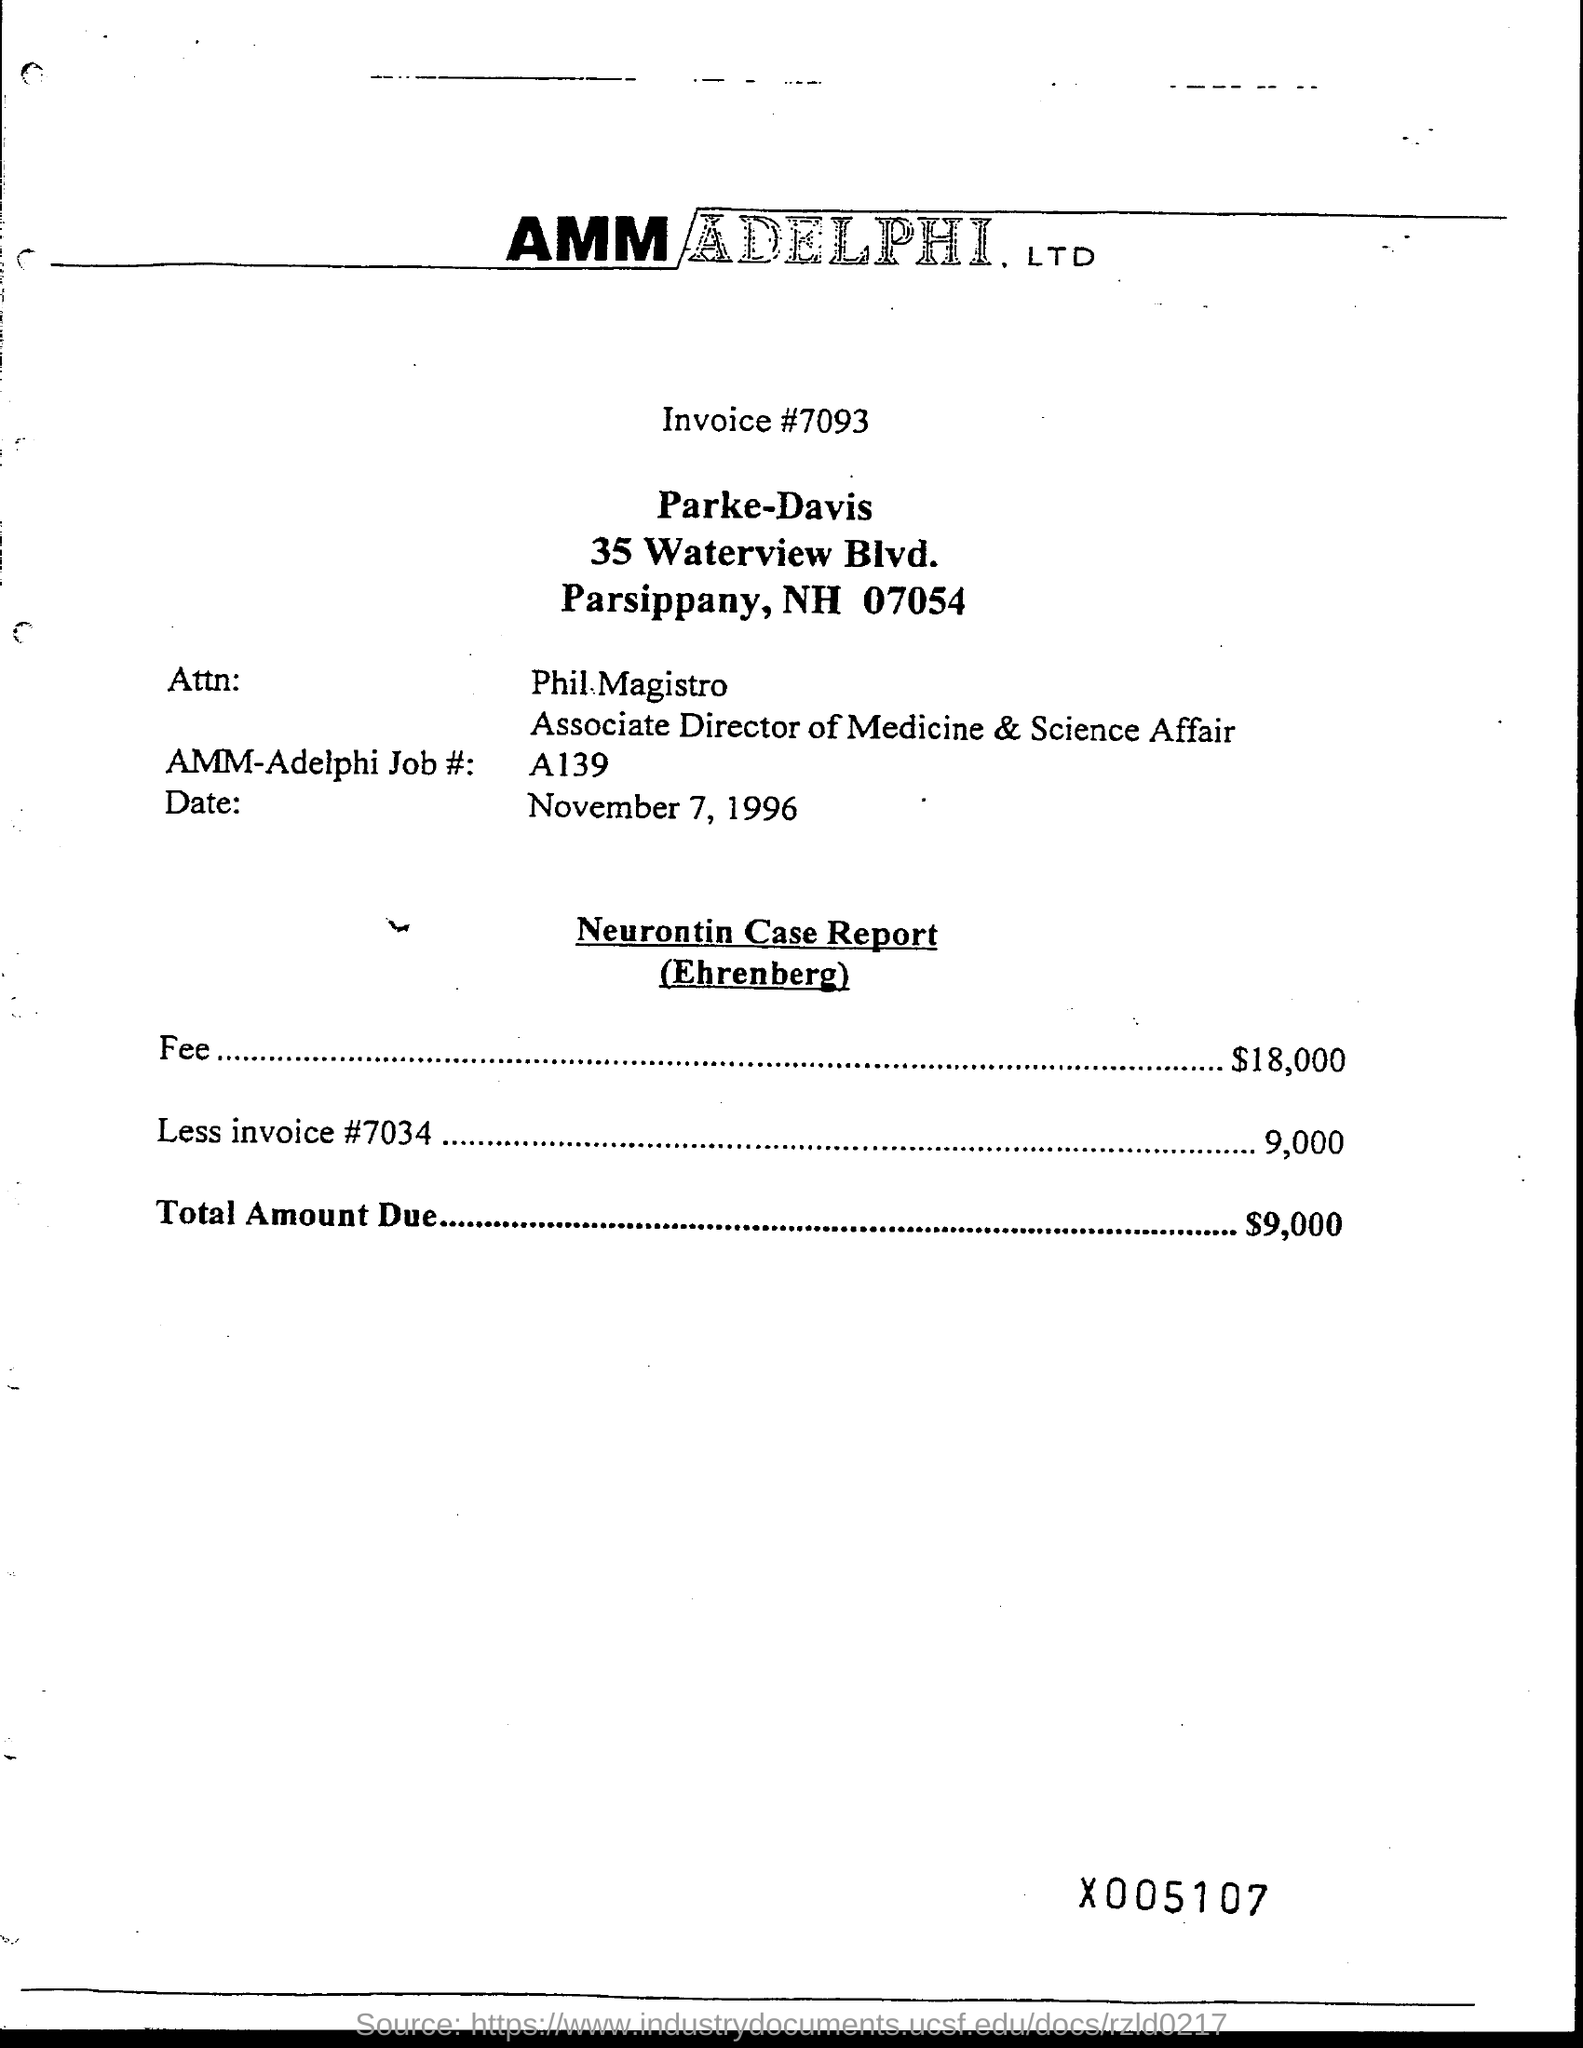Outline some significant characteristics in this image. The fee amount is 18000. The total amount due is 9000... The invoice number is #7093. 